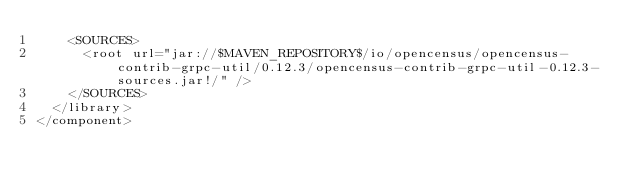Convert code to text. <code><loc_0><loc_0><loc_500><loc_500><_XML_>    <SOURCES>
      <root url="jar://$MAVEN_REPOSITORY$/io/opencensus/opencensus-contrib-grpc-util/0.12.3/opencensus-contrib-grpc-util-0.12.3-sources.jar!/" />
    </SOURCES>
  </library>
</component></code> 